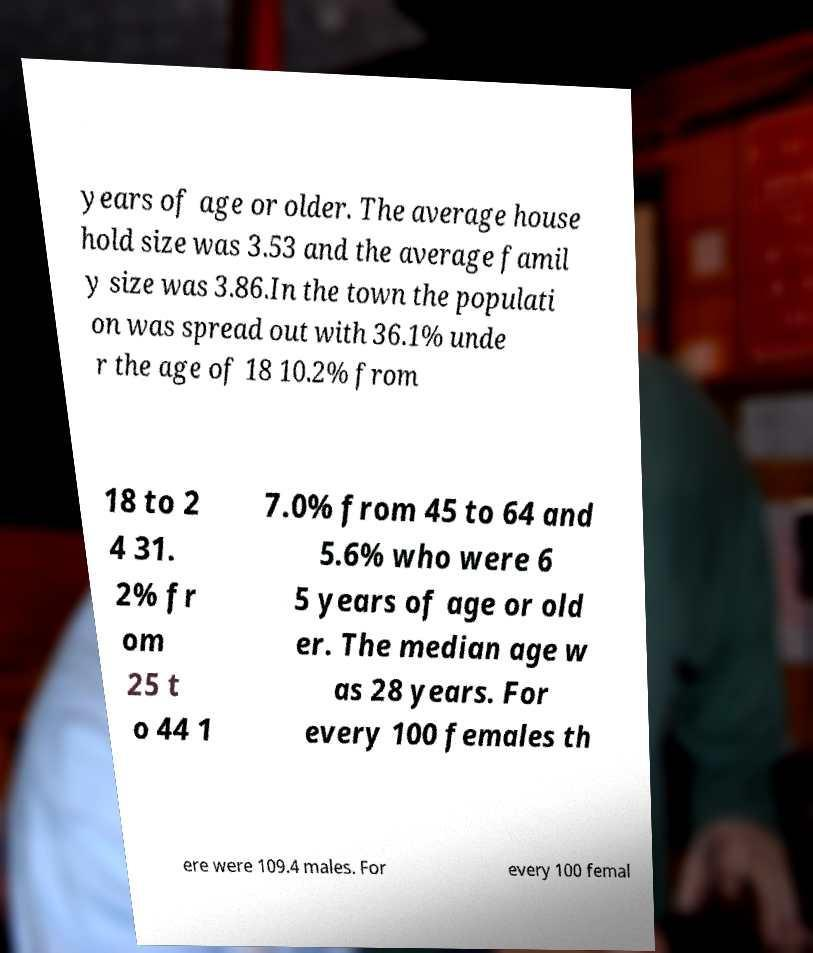I need the written content from this picture converted into text. Can you do that? years of age or older. The average house hold size was 3.53 and the average famil y size was 3.86.In the town the populati on was spread out with 36.1% unde r the age of 18 10.2% from 18 to 2 4 31. 2% fr om 25 t o 44 1 7.0% from 45 to 64 and 5.6% who were 6 5 years of age or old er. The median age w as 28 years. For every 100 females th ere were 109.4 males. For every 100 femal 